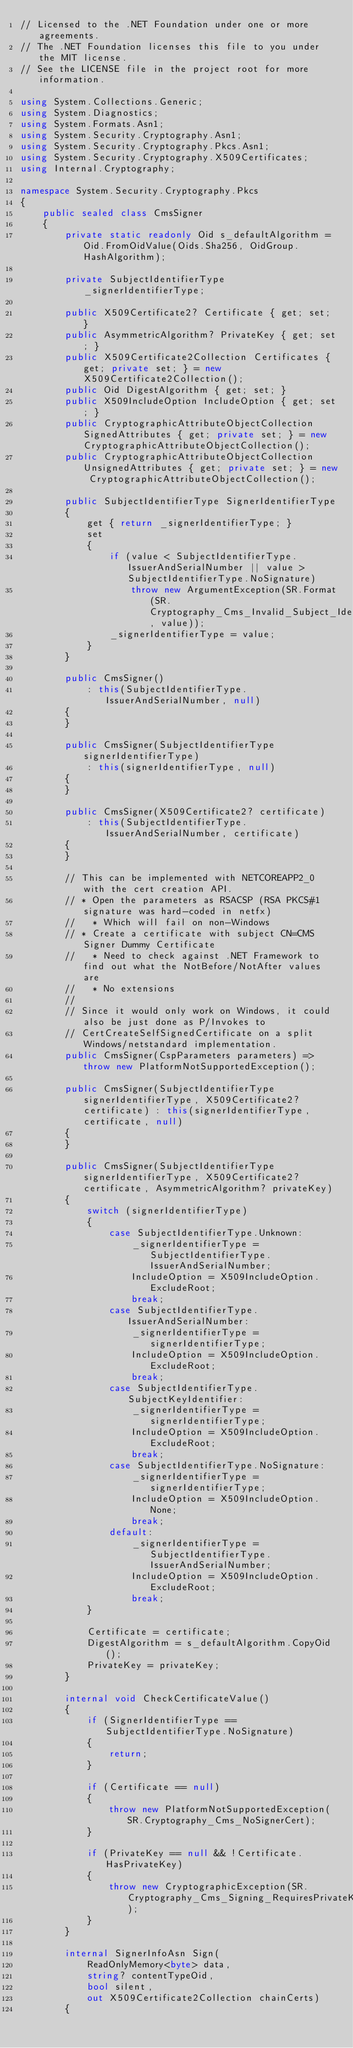<code> <loc_0><loc_0><loc_500><loc_500><_C#_>// Licensed to the .NET Foundation under one or more agreements.
// The .NET Foundation licenses this file to you under the MIT license.
// See the LICENSE file in the project root for more information.

using System.Collections.Generic;
using System.Diagnostics;
using System.Formats.Asn1;
using System.Security.Cryptography.Asn1;
using System.Security.Cryptography.Pkcs.Asn1;
using System.Security.Cryptography.X509Certificates;
using Internal.Cryptography;

namespace System.Security.Cryptography.Pkcs
{
    public sealed class CmsSigner
    {
        private static readonly Oid s_defaultAlgorithm = Oid.FromOidValue(Oids.Sha256, OidGroup.HashAlgorithm);

        private SubjectIdentifierType _signerIdentifierType;

        public X509Certificate2? Certificate { get; set; }
        public AsymmetricAlgorithm? PrivateKey { get; set; }
        public X509Certificate2Collection Certificates { get; private set; } = new X509Certificate2Collection();
        public Oid DigestAlgorithm { get; set; }
        public X509IncludeOption IncludeOption { get; set; }
        public CryptographicAttributeObjectCollection SignedAttributes { get; private set; } = new CryptographicAttributeObjectCollection();
        public CryptographicAttributeObjectCollection UnsignedAttributes { get; private set; } = new CryptographicAttributeObjectCollection();

        public SubjectIdentifierType SignerIdentifierType
        {
            get { return _signerIdentifierType; }
            set
            {
                if (value < SubjectIdentifierType.IssuerAndSerialNumber || value > SubjectIdentifierType.NoSignature)
                    throw new ArgumentException(SR.Format(SR.Cryptography_Cms_Invalid_Subject_Identifier_Type, value));
                _signerIdentifierType = value;
            }
        }

        public CmsSigner()
            : this(SubjectIdentifierType.IssuerAndSerialNumber, null)
        {
        }

        public CmsSigner(SubjectIdentifierType signerIdentifierType)
            : this(signerIdentifierType, null)
        {
        }

        public CmsSigner(X509Certificate2? certificate)
            : this(SubjectIdentifierType.IssuerAndSerialNumber, certificate)
        {
        }

        // This can be implemented with NETCOREAPP2_0 with the cert creation API.
        // * Open the parameters as RSACSP (RSA PKCS#1 signature was hard-coded in netfx)
        //   * Which will fail on non-Windows
        // * Create a certificate with subject CN=CMS Signer Dummy Certificate
        //   * Need to check against .NET Framework to find out what the NotBefore/NotAfter values are
        //   * No extensions
        //
        // Since it would only work on Windows, it could also be just done as P/Invokes to
        // CertCreateSelfSignedCertificate on a split Windows/netstandard implementation.
        public CmsSigner(CspParameters parameters) => throw new PlatformNotSupportedException();

        public CmsSigner(SubjectIdentifierType signerIdentifierType, X509Certificate2? certificate) : this(signerIdentifierType, certificate, null)
        {
        }

        public CmsSigner(SubjectIdentifierType signerIdentifierType, X509Certificate2? certificate, AsymmetricAlgorithm? privateKey)
        {
            switch (signerIdentifierType)
            {
                case SubjectIdentifierType.Unknown:
                    _signerIdentifierType = SubjectIdentifierType.IssuerAndSerialNumber;
                    IncludeOption = X509IncludeOption.ExcludeRoot;
                    break;
                case SubjectIdentifierType.IssuerAndSerialNumber:
                    _signerIdentifierType = signerIdentifierType;
                    IncludeOption = X509IncludeOption.ExcludeRoot;
                    break;
                case SubjectIdentifierType.SubjectKeyIdentifier:
                    _signerIdentifierType = signerIdentifierType;
                    IncludeOption = X509IncludeOption.ExcludeRoot;
                    break;
                case SubjectIdentifierType.NoSignature:
                    _signerIdentifierType = signerIdentifierType;
                    IncludeOption = X509IncludeOption.None;
                    break;
                default:
                    _signerIdentifierType = SubjectIdentifierType.IssuerAndSerialNumber;
                    IncludeOption = X509IncludeOption.ExcludeRoot;
                    break;
            }

            Certificate = certificate;
            DigestAlgorithm = s_defaultAlgorithm.CopyOid();
            PrivateKey = privateKey;
        }

        internal void CheckCertificateValue()
        {
            if (SignerIdentifierType == SubjectIdentifierType.NoSignature)
            {
                return;
            }

            if (Certificate == null)
            {
                throw new PlatformNotSupportedException(SR.Cryptography_Cms_NoSignerCert);
            }

            if (PrivateKey == null && !Certificate.HasPrivateKey)
            {
                throw new CryptographicException(SR.Cryptography_Cms_Signing_RequiresPrivateKey);
            }
        }

        internal SignerInfoAsn Sign(
            ReadOnlyMemory<byte> data,
            string? contentTypeOid,
            bool silent,
            out X509Certificate2Collection chainCerts)
        {</code> 